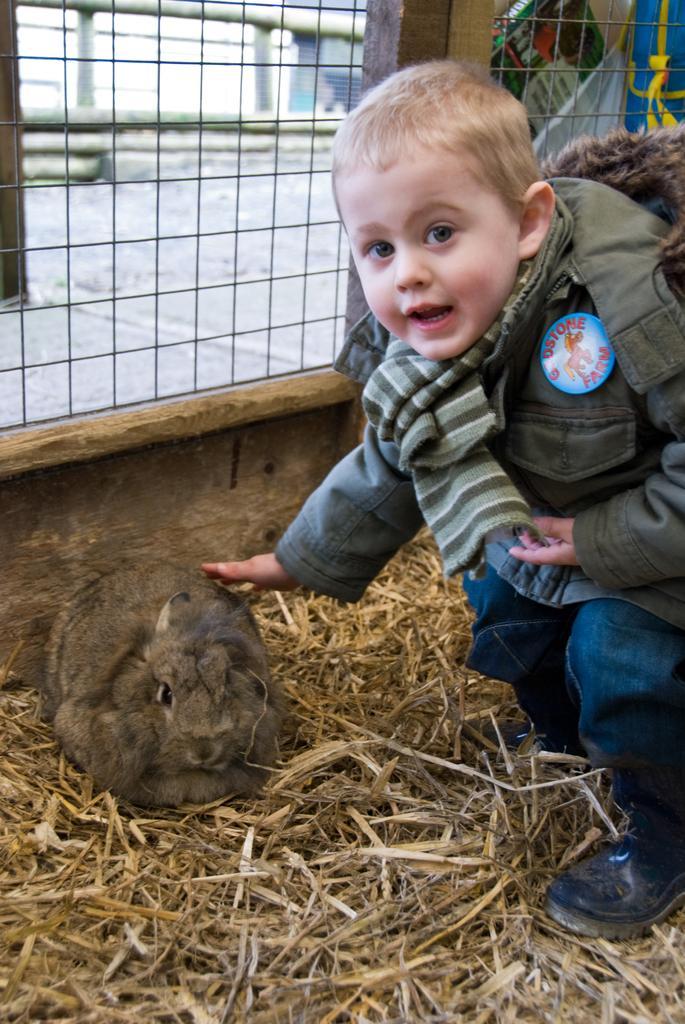How would you summarize this image in a sentence or two? In this image there is a rabbit on a grass and a boy touching the rabbit, in the background there is fencing. 